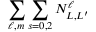Convert formula to latex. <formula><loc_0><loc_0><loc_500><loc_500>\sum _ { \ell , m } \sum _ { s = 0 , 2 } N _ { L , L ^ { \prime } } ^ { \ell }</formula> 